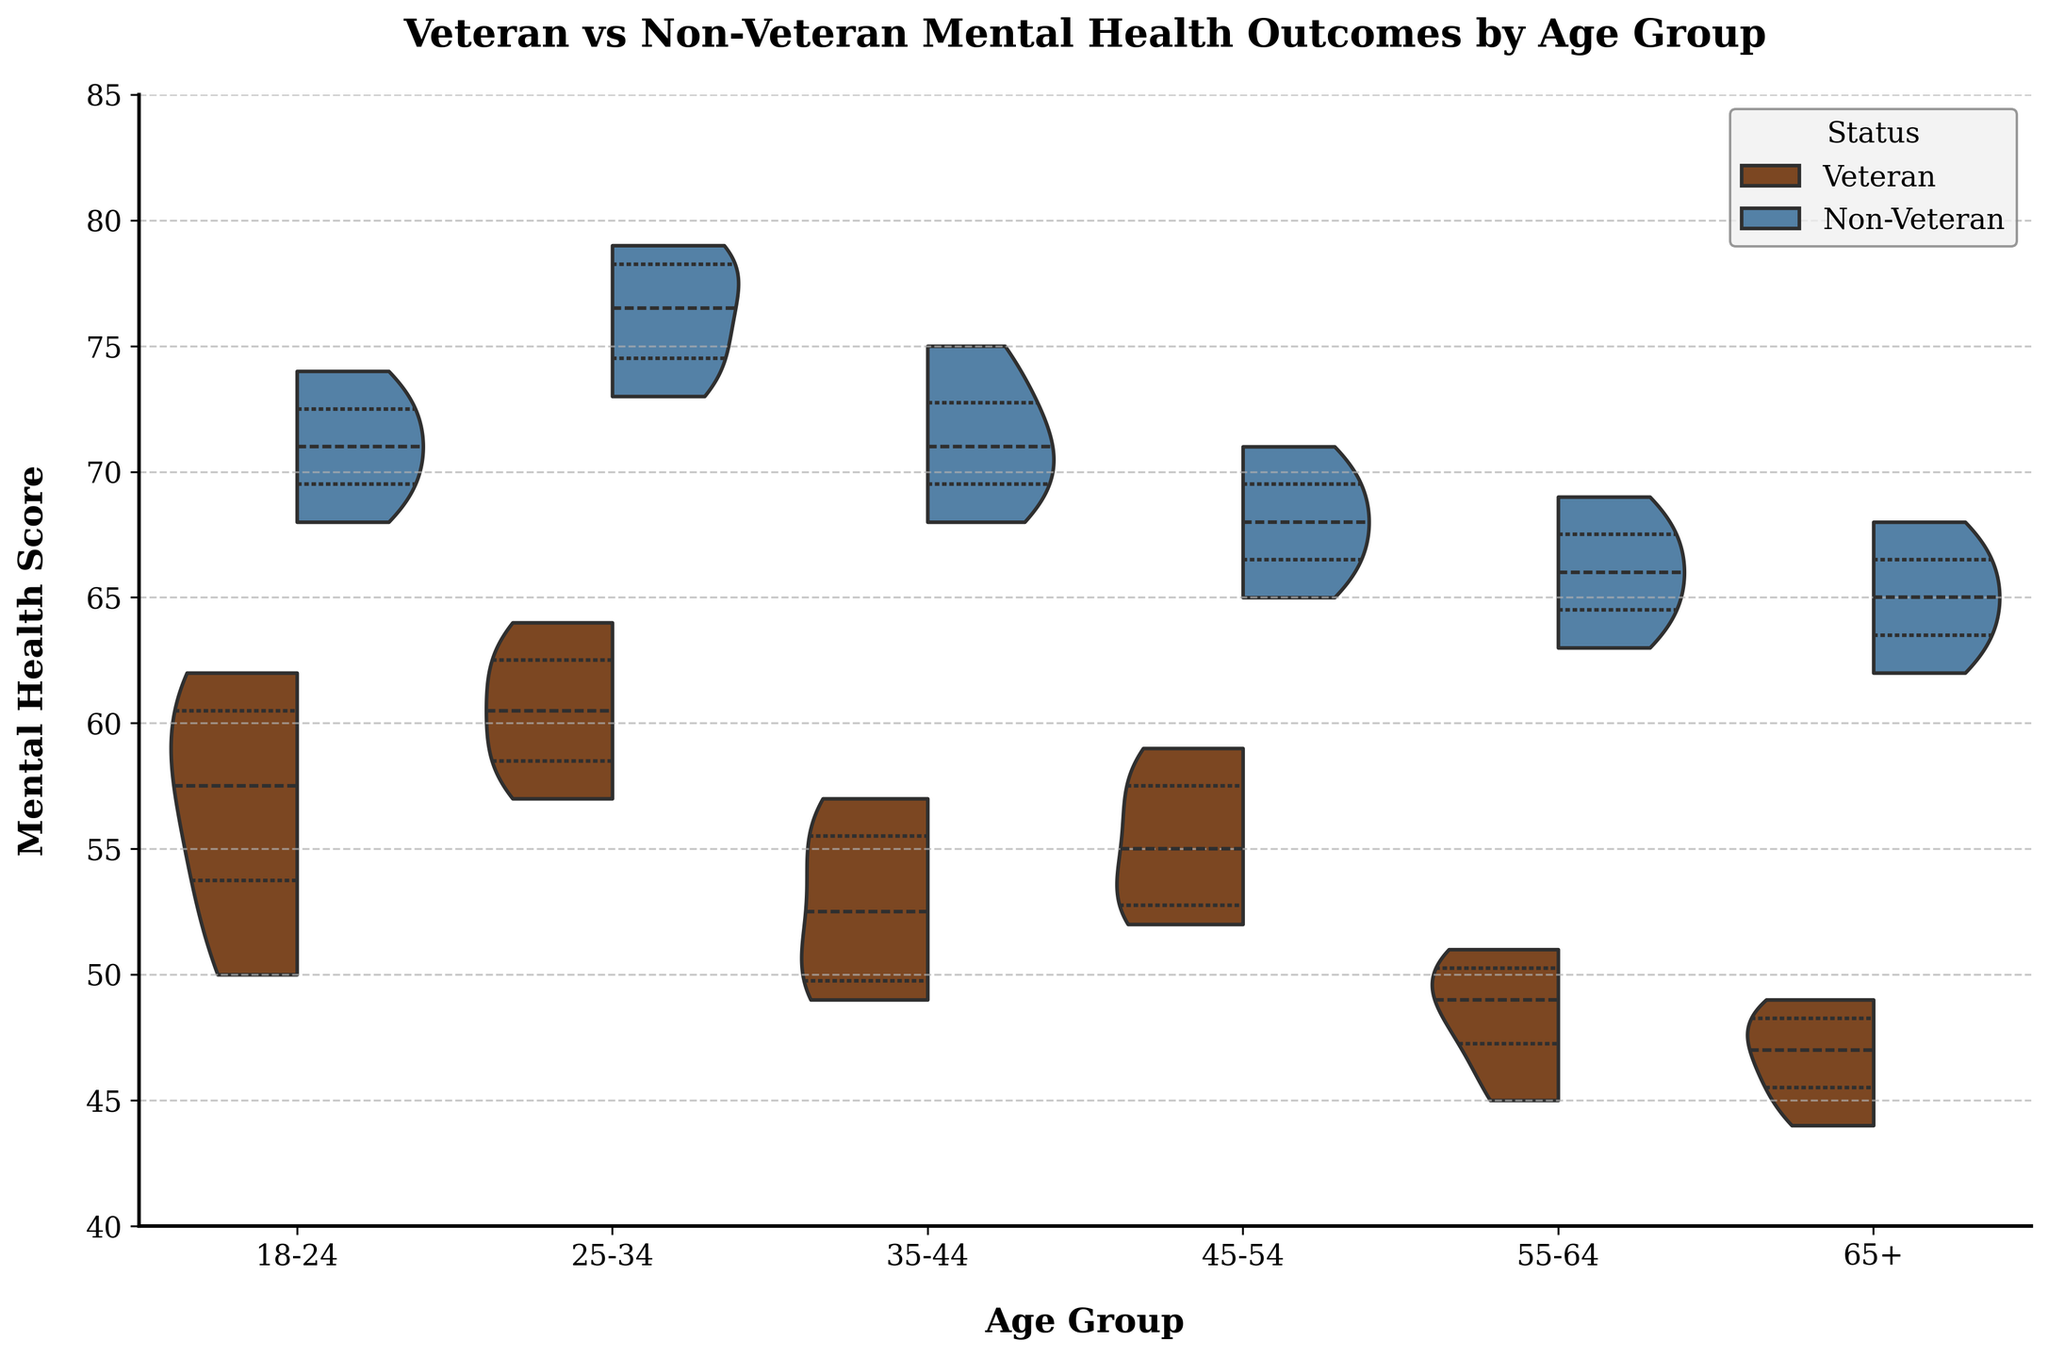What is the title of the figure? The title is located at the top of the figure and provides an overall description of what the figure represents.
Answer: Veteran vs Non-Veteran Mental Health Outcomes by Age Group What is the x-axis label in the figure? The x-axis label is located beneath the horizontal axis and indicates what variable the axis represents.
Answer: Age Group What is the y-axis label in the figure? The y-axis label is positioned beside the vertical axis and signifies the variable this axis represents.
Answer: Mental Health Score What age group shows the largest difference in mental health scores between veterans and non-veterans? Observing the Split Violin Chart, the '65+' age group has the most extended non-overlapping areas between veterans and non-veterans, indicating the largest difference in mental health scores.
Answer: 65+ Which status group has a generally higher mental health score across all age groups? By looking at the Split Violin Chart, it is evident that non-veterans have their distribution graphs higher than veterans across all age groups, indicating that non-veterans generally have higher mental health scores.
Answer: Non-Veteran In which age group do both veterans and non-veterans show the closest mental health scores? The age group '45-54' has the violin plots of both veterans and non-veterans closely overlapping throughout most of the mental health score range, indicating the closest scores between the two groups.
Answer: 45-54 How does the mental health score distribution for veterans change as age increases? Observing the violin plots for veterans, the distributions shift towards lower mental health scores with increasing age, showing a trend of decreasing mental health scores as one gets older.
Answer: Decreases Which age group has the overall highest mental health scores for non-veterans? The non-veteran plots for the age group '25-34' show the highest distribution of mental health scores overall, indicating this age group has the highest scores among non-veterans.
Answer: 25-34 Are the mental health score distributions wider for veterans or non-veterans within each age group? By comparing the width of the Split Violin plots for veterans and non-veterans in each age group, it can be observed that non-veterans generally have wider distributions.
Answer: Non-Veterans What is the median mental health score for veterans aged 35-44? The median is represented by the middle line in the box plot (quartile lines) within the violin plot. For veterans aged 35-44, this line is around the score of 52-53.
Answer: Around 52-53 